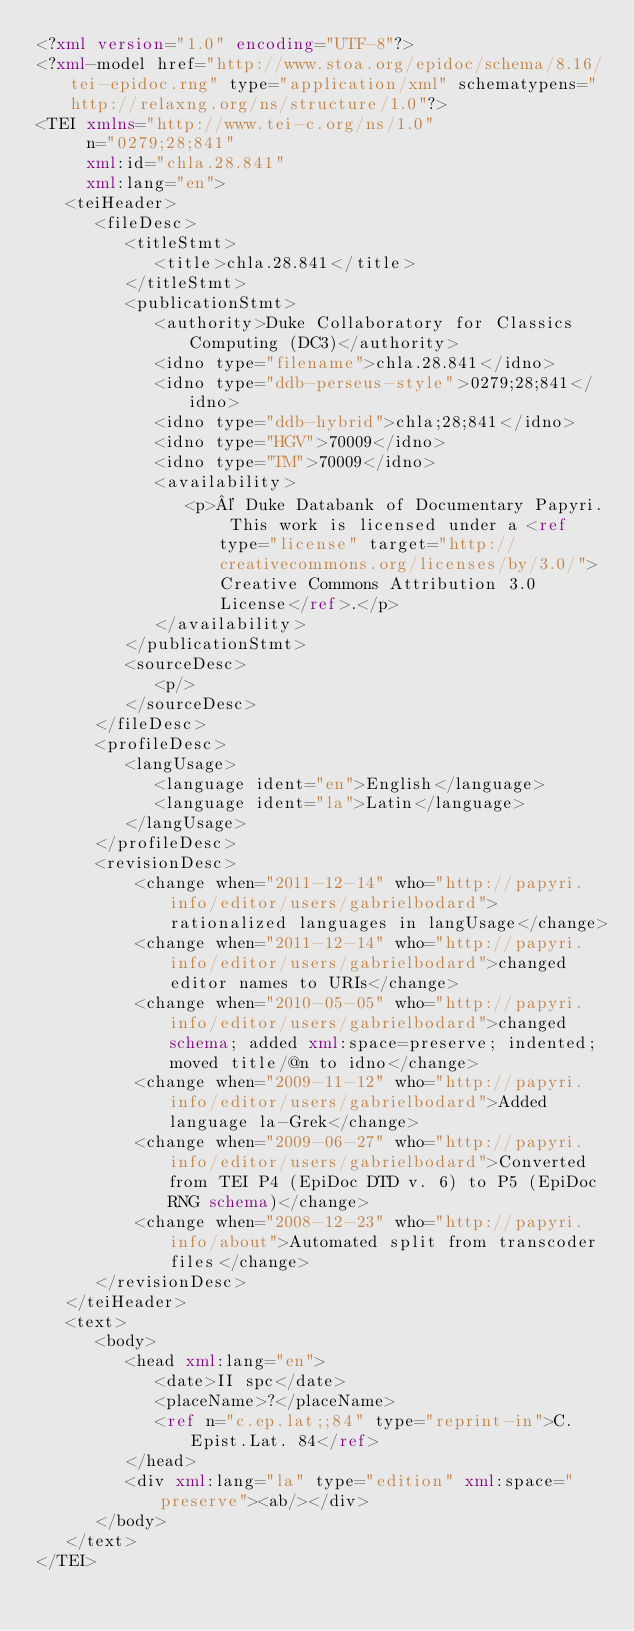Convert code to text. <code><loc_0><loc_0><loc_500><loc_500><_XML_><?xml version="1.0" encoding="UTF-8"?>
<?xml-model href="http://www.stoa.org/epidoc/schema/8.16/tei-epidoc.rng" type="application/xml" schematypens="http://relaxng.org/ns/structure/1.0"?>
<TEI xmlns="http://www.tei-c.org/ns/1.0"
     n="0279;28;841"
     xml:id="chla.28.841"
     xml:lang="en">
   <teiHeader>
      <fileDesc>
         <titleStmt>
            <title>chla.28.841</title>
         </titleStmt>
         <publicationStmt>
            <authority>Duke Collaboratory for Classics Computing (DC3)</authority>
            <idno type="filename">chla.28.841</idno>
            <idno type="ddb-perseus-style">0279;28;841</idno>
            <idno type="ddb-hybrid">chla;28;841</idno>
            <idno type="HGV">70009</idno>
            <idno type="TM">70009</idno>
            <availability>
               <p>© Duke Databank of Documentary Papyri. This work is licensed under a <ref type="license" target="http://creativecommons.org/licenses/by/3.0/">Creative Commons Attribution 3.0 License</ref>.</p>
            </availability>
         </publicationStmt>
         <sourceDesc>
            <p/>
         </sourceDesc>
      </fileDesc>
      <profileDesc>
         <langUsage>
            <language ident="en">English</language>
            <language ident="la">Latin</language>
         </langUsage>
      </profileDesc>
      <revisionDesc>
          <change when="2011-12-14" who="http://papyri.info/editor/users/gabrielbodard">rationalized languages in langUsage</change>
          <change when="2011-12-14" who="http://papyri.info/editor/users/gabrielbodard">changed editor names to URIs</change>
          <change when="2010-05-05" who="http://papyri.info/editor/users/gabrielbodard">changed schema; added xml:space=preserve; indented; moved title/@n to idno</change>
          <change when="2009-11-12" who="http://papyri.info/editor/users/gabrielbodard">Added language la-Grek</change>
          <change when="2009-06-27" who="http://papyri.info/editor/users/gabrielbodard">Converted from TEI P4 (EpiDoc DTD v. 6) to P5 (EpiDoc RNG schema)</change>
          <change when="2008-12-23" who="http://papyri.info/about">Automated split from transcoder files</change>
      </revisionDesc>
   </teiHeader>
   <text>
      <body>
         <head xml:lang="en">
            <date>II spc</date>
            <placeName>?</placeName>
            <ref n="c.ep.lat;;84" type="reprint-in">C.Epist.Lat. 84</ref>
         </head>
         <div xml:lang="la" type="edition" xml:space="preserve"><ab/></div>
      </body>
   </text>
</TEI>
</code> 